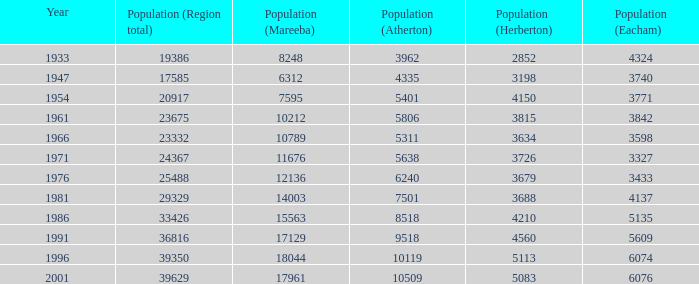How many digits are presented for the region's sum in 1947? 1.0. 